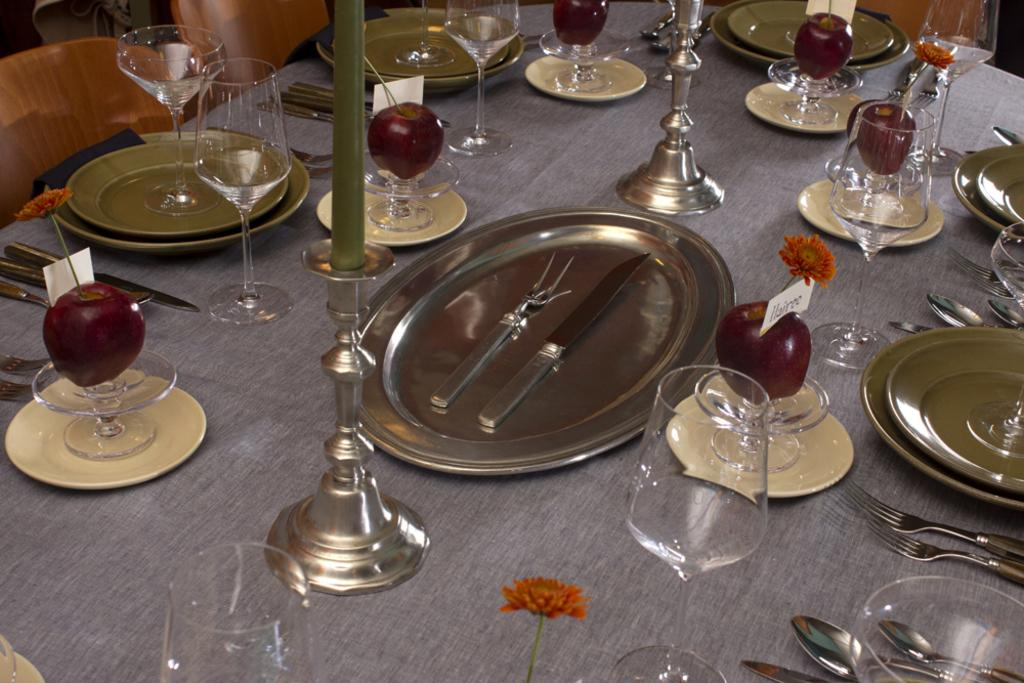What objects are present on the table in the image? There are plates, knives, candle stands, glasses, and fruits on the table. What might be used for cutting in the image? Knives are present on the table for cutting. What objects might be used for holding or displaying something in the image? Candle stands are present on the table for holding or displaying candles. What objects might be used for drinking in the image? Glasses are present on the table for drinking. What type of food is visible on the table? Fruits are visible on the table. Where is the loaf of bread located in the image? There is no loaf of bread present in the image. What type of collar is visible on the fruits in the image? There are no collars present in the image, as fruits do not have collars. 